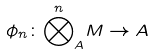Convert formula to latex. <formula><loc_0><loc_0><loc_500><loc_500>\phi _ { n } \colon { \overset { n } { \bigotimes } _ { A } } M \rightarrow A</formula> 